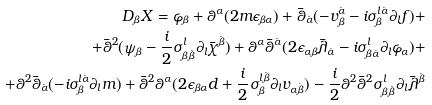Convert formula to latex. <formula><loc_0><loc_0><loc_500><loc_500>D _ { \beta } X = \varphi _ { \beta } + \theta ^ { \alpha } ( 2 m \epsilon _ { \beta \alpha } ) + \bar { \theta } _ { \dot { \alpha } } ( - v _ { \beta } ^ { \dot { \alpha } } - i \sigma _ { \beta } ^ { l \dot { \alpha } } \partial _ { l } f ) + \\ + \bar { \theta } ^ { 2 } ( \psi _ { \beta } - \frac { i } { 2 } \sigma _ { \beta \dot { \beta } } ^ { l } \partial _ { l } \bar { \chi } ^ { \dot { \beta } } ) + \theta ^ { \alpha } \bar { \theta } ^ { \dot { \alpha } } ( 2 \epsilon _ { \alpha \beta } \bar { \lambda } _ { \dot { \alpha } } - i \sigma _ { \beta \dot { \alpha } } ^ { l } \partial _ { l } \varphi _ { \alpha } ) + \\ + \theta ^ { 2 } \bar { \theta } _ { \dot { \alpha } } ( - i \sigma _ { \beta } ^ { l \dot { \alpha } } \partial _ { l } m ) + \bar { \theta } ^ { 2 } \theta ^ { \alpha } ( 2 \epsilon _ { \beta \alpha } d + \frac { i } { 2 } \sigma _ { \beta } ^ { l \dot { \beta } } \partial _ { l } v _ { \alpha \dot { \beta } } ) - \frac { i } { 2 } \theta ^ { 2 } \bar { \theta } ^ { 2 } \sigma _ { \beta \dot { \beta } } ^ { l } \partial _ { l } \bar { \lambda } ^ { \dot { \beta } }</formula> 